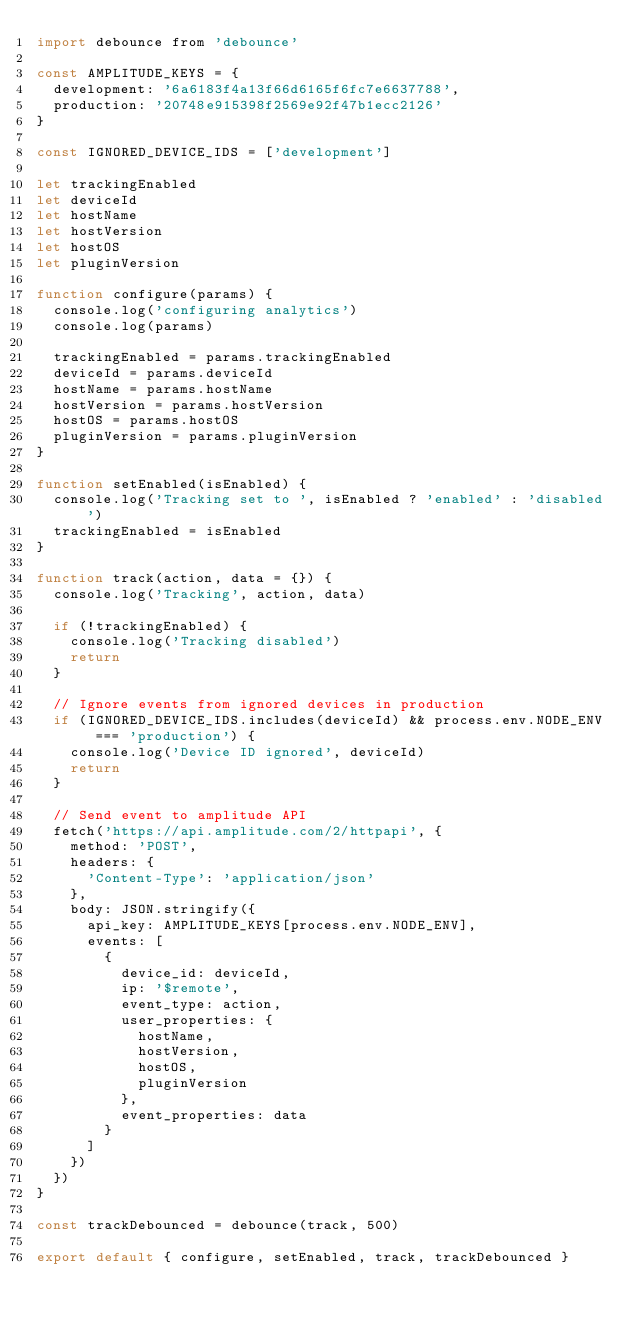<code> <loc_0><loc_0><loc_500><loc_500><_JavaScript_>import debounce from 'debounce'

const AMPLITUDE_KEYS = {
  development: '6a6183f4a13f66d6165f6fc7e6637788',
  production: '20748e915398f2569e92f47b1ecc2126'
}

const IGNORED_DEVICE_IDS = ['development']

let trackingEnabled
let deviceId
let hostName
let hostVersion
let hostOS
let pluginVersion

function configure(params) {
  console.log('configuring analytics')
  console.log(params)

  trackingEnabled = params.trackingEnabled
  deviceId = params.deviceId
  hostName = params.hostName
  hostVersion = params.hostVersion
  hostOS = params.hostOS
  pluginVersion = params.pluginVersion
}

function setEnabled(isEnabled) {
  console.log('Tracking set to ', isEnabled ? 'enabled' : 'disabled')
  trackingEnabled = isEnabled
}

function track(action, data = {}) {
  console.log('Tracking', action, data)

  if (!trackingEnabled) {
    console.log('Tracking disabled')
    return
  }

  // Ignore events from ignored devices in production
  if (IGNORED_DEVICE_IDS.includes(deviceId) && process.env.NODE_ENV === 'production') {
    console.log('Device ID ignored', deviceId)
    return
  }

  // Send event to amplitude API
  fetch('https://api.amplitude.com/2/httpapi', {
    method: 'POST',
    headers: {
      'Content-Type': 'application/json'
    },
    body: JSON.stringify({
      api_key: AMPLITUDE_KEYS[process.env.NODE_ENV],
      events: [
        {
          device_id: deviceId,
          ip: '$remote',
          event_type: action,
          user_properties: {
            hostName,
            hostVersion,
            hostOS,
            pluginVersion
          },
          event_properties: data
        }
      ]
    })
  })
}

const trackDebounced = debounce(track, 500)

export default { configure, setEnabled, track, trackDebounced }
</code> 